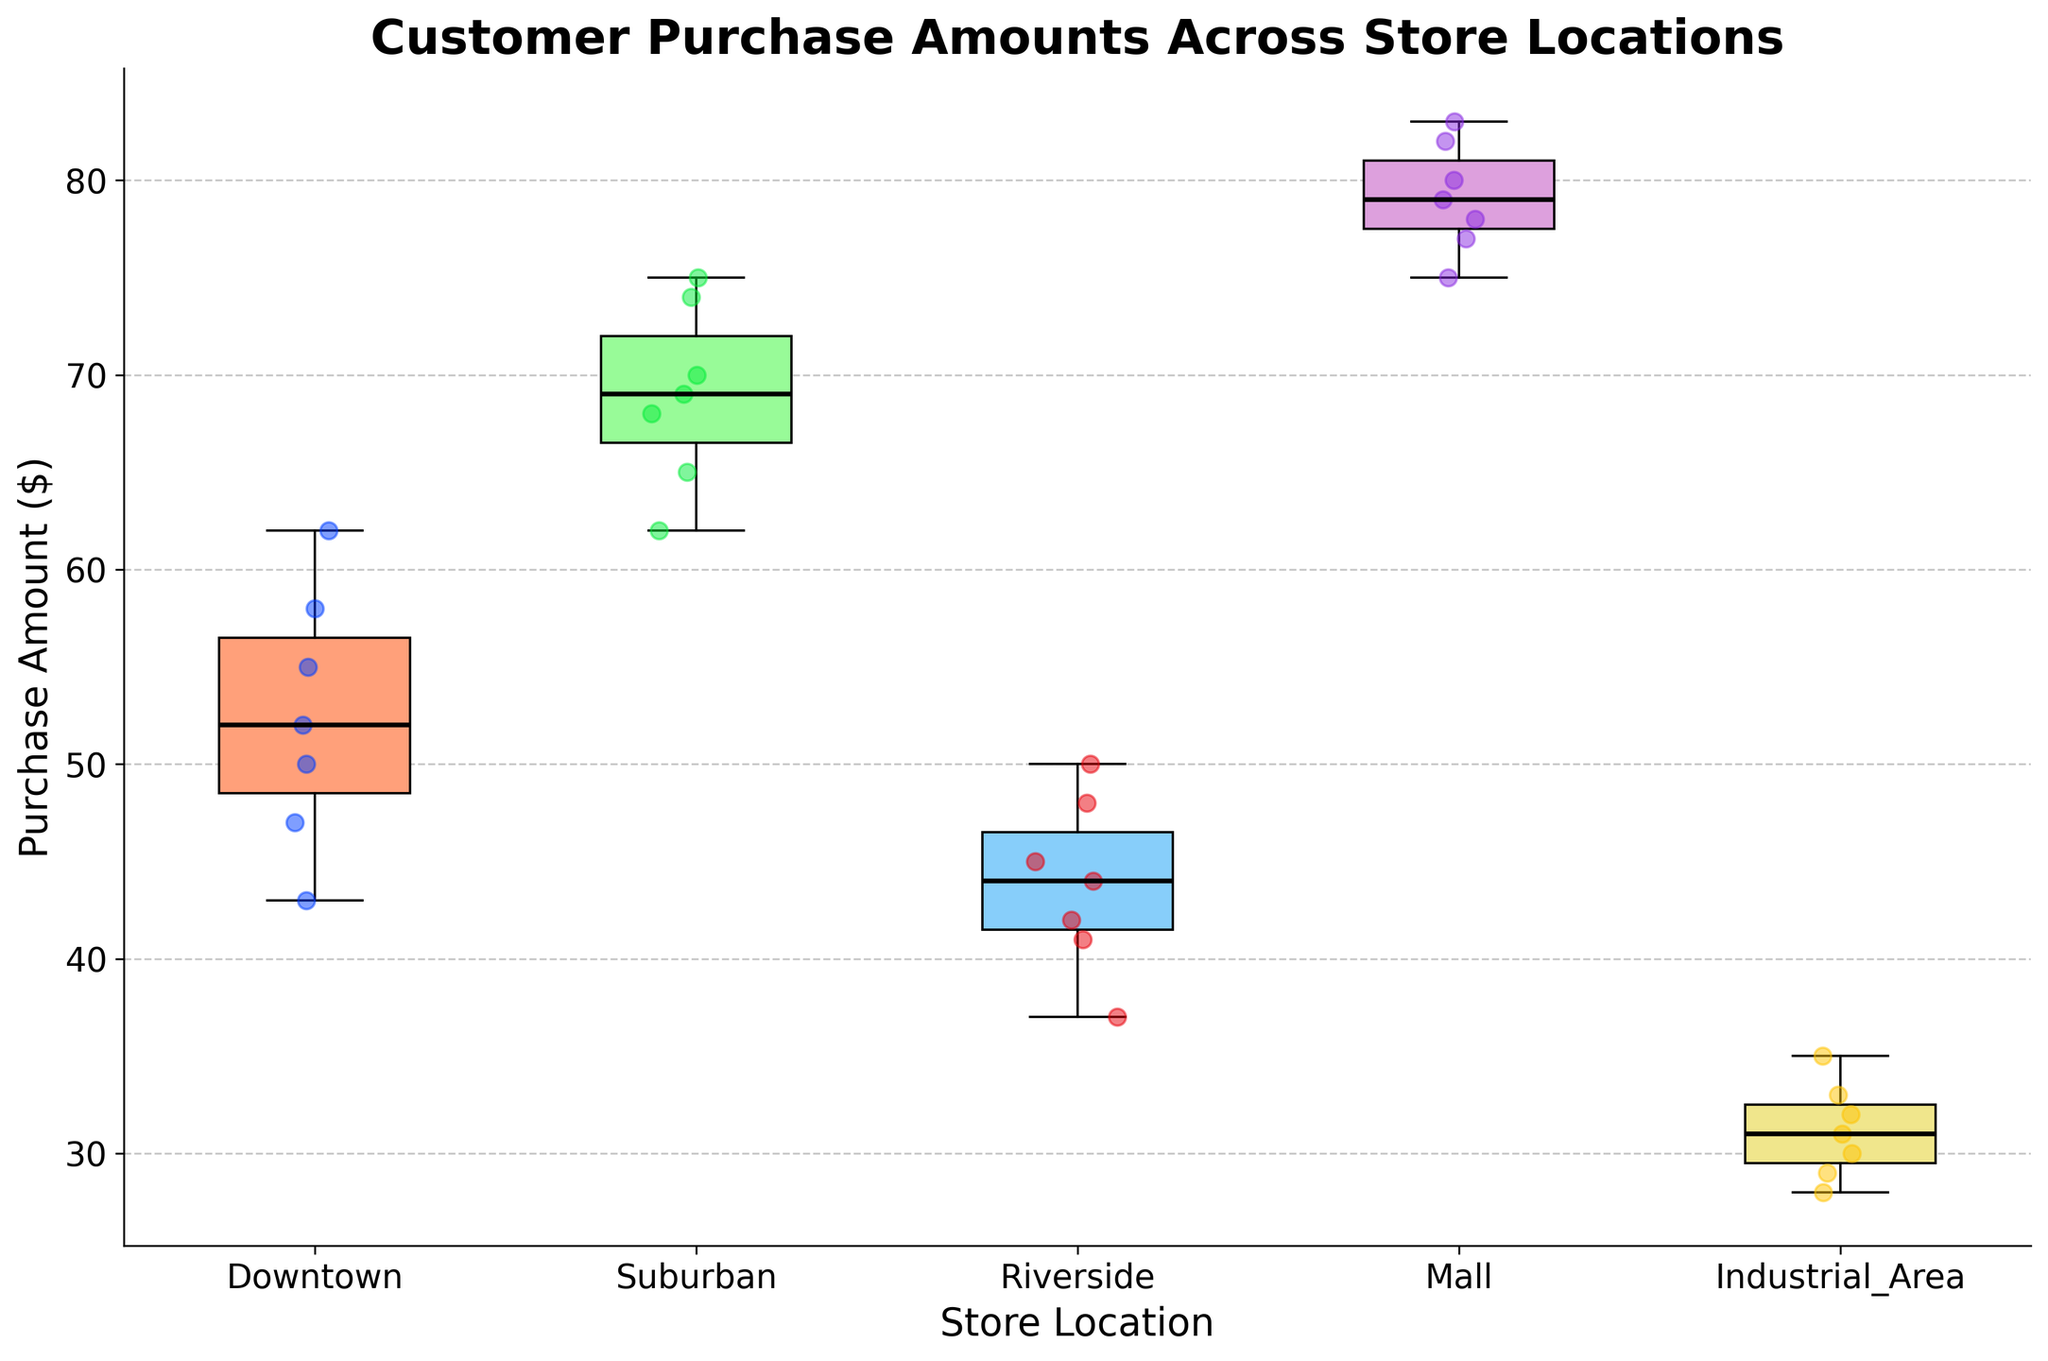What's the title of the plot? The title of the plot is displayed at the top and reads 'Customer Purchase Amounts Across Store Locations'.
Answer: Customer Purchase Amounts Across Store Locations What is the range of purchase amounts in the Industrial Area? The range is determined by the difference between the maximum and minimum values in the box plot for the Industrial Area. The minimum (lower whisker) is 28 and the maximum (upper whisker) is 35. So, the range is 35 - 28.
Answer: 7 Which store location has the highest median purchase amount? The median values can be seen as the horizontal lines inside the box for each store location. The Mall has the highest median, as its median line is the highest among all.
Answer: Mall How does the spread of purchase amounts in the Downtown location compare to the Suburban location? The spread can be compared by looking at the interquartile range (IQR) and the overall range (whiskers). The IQR for Downtown is narrower compared to the Suburban, indicating lesser variability in the middle 50% of the data in Downtown.
Answer: Downtown has a narrower spread Which store location has the most outliers and how many are there? Outliers are shown as individual points outside the whiskers. The Mall has the most outliers with two outliers marked by red diamonds above the upper whisker.
Answer: Mall, 2 What is the approximate median purchase amount at the Riverside location? The median is the horizontal line inside the box for Riverside. This line appears near the value of 45.
Answer: 45 Which store location has the lowest purchase amount and what is it? The lowest purchase amount is indicated by the lowest point of the lower whisker. The Industrial Area has the lowest purchase amount at 28.
Answer: Industrial Area, 28 Compare the upper whisker of the Downtown and Riverside locations, which one is higher? The upper whisker represents the maximum value excluding outliers. For Downtown, the upper whisker is at 62 and for Riverside, it is at 50. Therefore, Downtown's upper whisker is higher.
Answer: Downtown What is the interquartile range (IQR) for the Mall location? The IQR is calculated by subtracting the first quartile (lower boundary of the box) from the third quartile (upper boundary of the box). For the Mall, the lower boundary is around 77 and the upper boundary is around 82. So, IQR = 82 - 77.
Answer: 5 